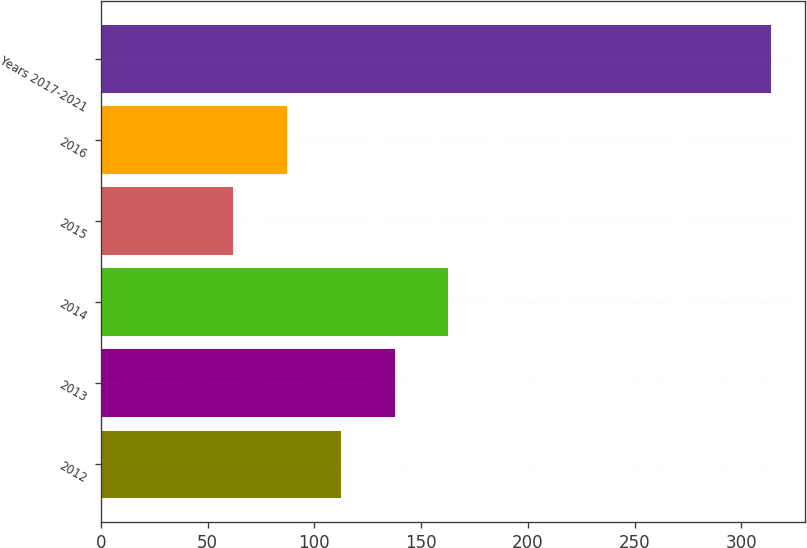<chart> <loc_0><loc_0><loc_500><loc_500><bar_chart><fcel>2012<fcel>2013<fcel>2014<fcel>2015<fcel>2016<fcel>Years 2017-2021<nl><fcel>112.4<fcel>137.6<fcel>162.8<fcel>62<fcel>87.2<fcel>314<nl></chart> 